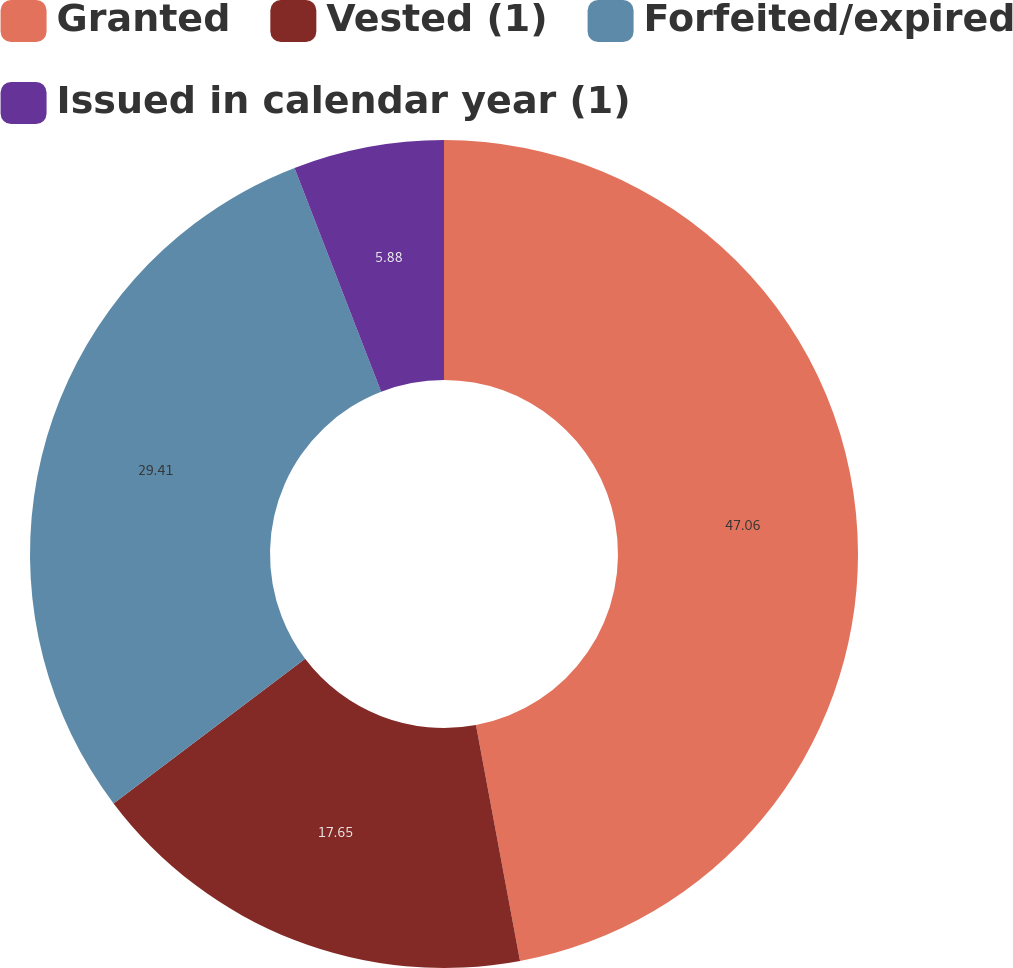Convert chart. <chart><loc_0><loc_0><loc_500><loc_500><pie_chart><fcel>Granted<fcel>Vested (1)<fcel>Forfeited/expired<fcel>Issued in calendar year (1)<nl><fcel>47.06%<fcel>17.65%<fcel>29.41%<fcel>5.88%<nl></chart> 